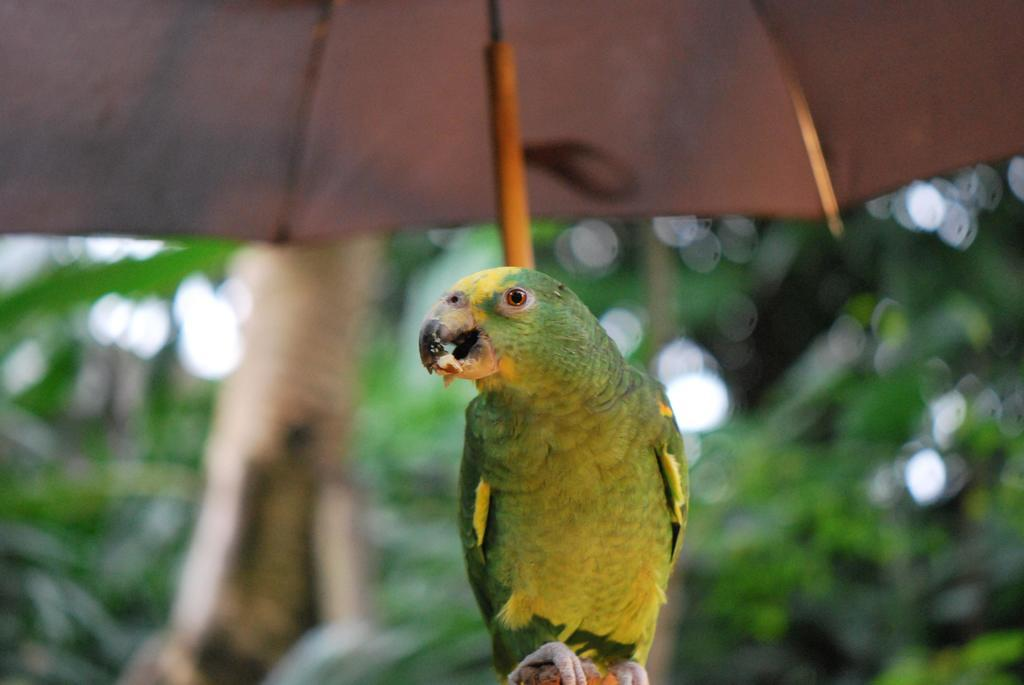What type of animal is in the image? There is a parrot in the image. What object is also present in the image? There is an umbrella in the image. Where is the ship located in the image? There is no ship present in the image. What is the mass of the parrot in the image? It is not possible to determine the mass of the parrot from the image alone. 